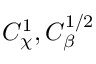Convert formula to latex. <formula><loc_0><loc_0><loc_500><loc_500>{ C } _ { \chi } ^ { 1 } , { C } _ { \beta } ^ { 1 / 2 }</formula> 